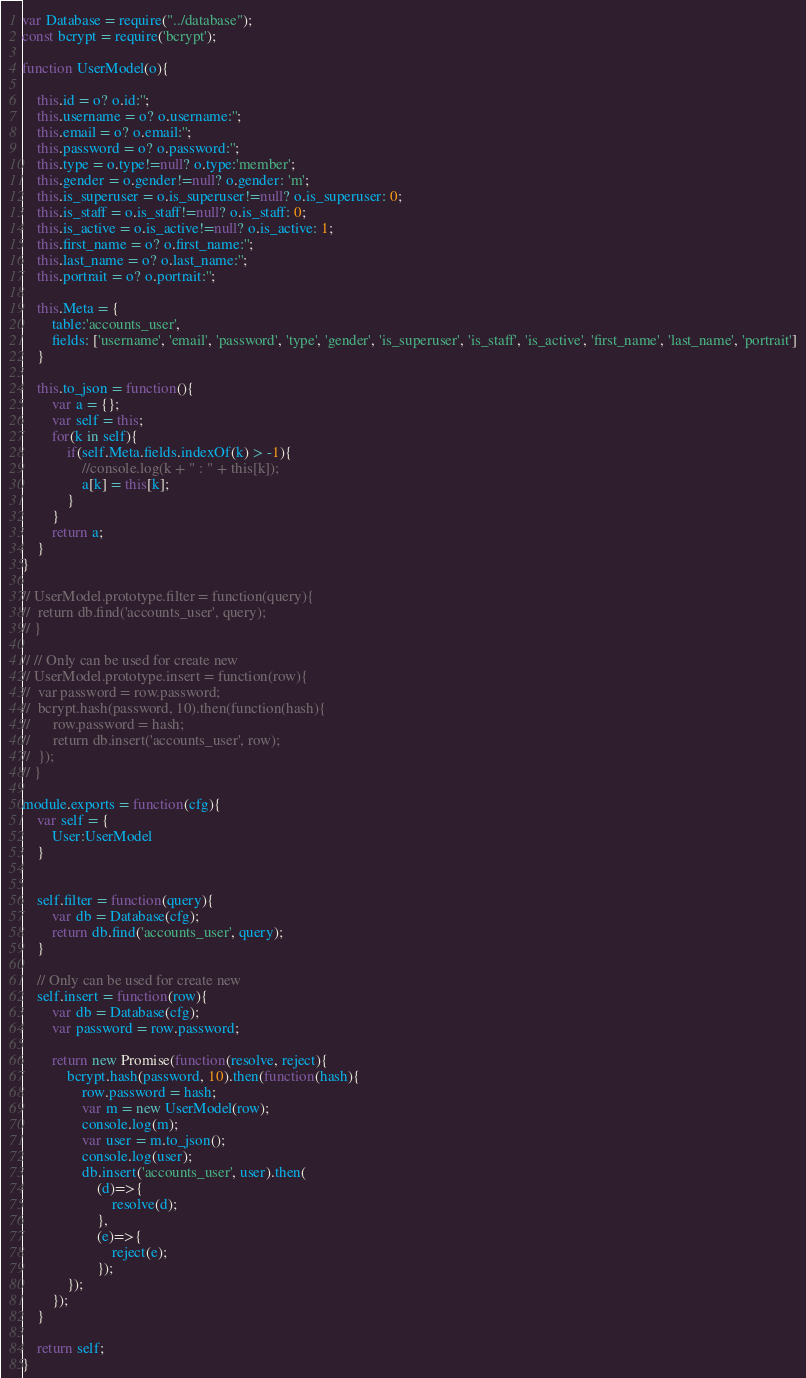<code> <loc_0><loc_0><loc_500><loc_500><_JavaScript_>var Database = require("../database");
const bcrypt = require('bcrypt');

function UserModel(o){

    this.id = o? o.id:'';
    this.username = o? o.username:'';
    this.email = o? o.email:'';
    this.password = o? o.password:'';
    this.type = o.type!=null? o.type:'member';
    this.gender = o.gender!=null? o.gender: 'm';
    this.is_superuser = o.is_superuser!=null? o.is_superuser: 0;
    this.is_staff = o.is_staff!=null? o.is_staff: 0;
    this.is_active = o.is_active!=null? o.is_active: 1;
    this.first_name = o? o.first_name:'';
    this.last_name = o? o.last_name:'';
    this.portrait = o? o.portrait:'';

    this.Meta = {
    	table:'accounts_user',
        fields: ['username', 'email', 'password', 'type', 'gender', 'is_superuser', 'is_staff', 'is_active', 'first_name', 'last_name', 'portrait']
    }

    this.to_json = function(){
        var a = {};
        var self = this;
        for(k in self){
            if(self.Meta.fields.indexOf(k) > -1){
                //console.log(k + " : " + this[k]);
                a[k] = this[k];
            }
        }
        return a;
    }
}

// UserModel.prototype.filter = function(query){
// 	return db.find('accounts_user', query);
// }

// // Only can be used for create new
// UserModel.prototype.insert = function(row){
// 	var password = row.password;
// 	bcrypt.hash(password, 10).then(function(hash){
// 		row.password = hash;
// 		return db.insert('accounts_user', row);
// 	});
// }

module.exports = function(cfg){
    var self = {
        User:UserModel
    }
    

    self.filter = function(query){
        var db = Database(cfg);
        return db.find('accounts_user', query);
    }

    // Only can be used for create new
    self.insert = function(row){
        var db = Database(cfg);
        var password = row.password;

        return new Promise(function(resolve, reject){
            bcrypt.hash(password, 10).then(function(hash){
                row.password = hash;
                var m = new UserModel(row);
                console.log(m);
                var user = m.to_json();
                console.log(user);
                db.insert('accounts_user', user).then(
                    (d)=>{
                        resolve(d);
                    },
                    (e)=>{
                        reject(e);
                    });
            });
        });
    }
    
    return self;
}</code> 